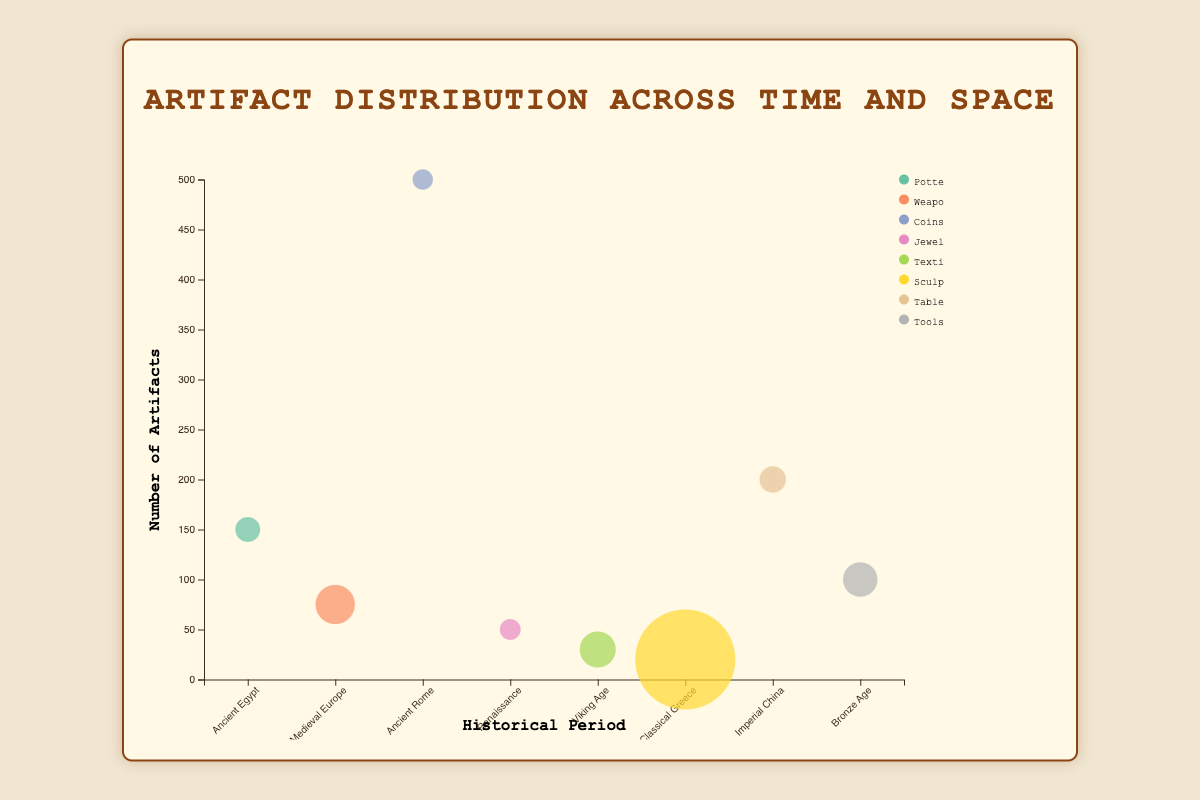What's the title of the chart? The title of the chart is displayed at the top center of the visual.
Answer: Artifact Distribution Across Time and Space How many total artifact categories are present? Count the distinct artifact categories represented by different colors in the bubble chart legend.
Answer: 8 Which artifact type has the largest average size? Look for the artifact category with the largest bubble, which indicates the largest average size (cm³).
Answer: Sculptures Which period and region have the highest number of artifacts? Identify the data point with the highest y-axis value representing the number of artifacts.
Answer: Ancient Rome, Italian Peninsula How many more artifacts are there in Ancient Rome compared to Medieval Europe? Calculate the difference between the number of artifacts in Ancient Rome and Medieval Europe. 500 (Ancient Rome) - 75 (Medieval Europe) = 425
Answer: 425 Which artifact type present during the Viking Age has the largest size? Identify the artifact type and period, then find the corresponding bubble size associated with the Viking Age.
Answer: Textiles Compare and contrast the number of artifacts between Imperial China and Bronze Age periods. Compare the y-axis values that represent the number of artifacts for these two periods. Imperial China has 200 artifacts whereas Bronze Age has 100 artifacts.
Answer: Imperial China has more Which historical period is represented by the artifact type Coins? Match the artifact type "Coins" to its corresponding period on the x-axis and tooltip.
Answer: Ancient Rome If we combine the number of artifacts from the Renaissance and Classical Greece periods, what is the total number? Sum the y-axis values representing the number of artifacts for both periods. Renaissance (50) + Classical Greece (20) = 70
Answer: 70 Is the average size of Pottery artifacts larger than that of Tools? Compare the sizes of the bubbles, particularly focusing on Pottery and Tools. The size of the Pottery bubble is smaller than that of Tools.
Answer: No 